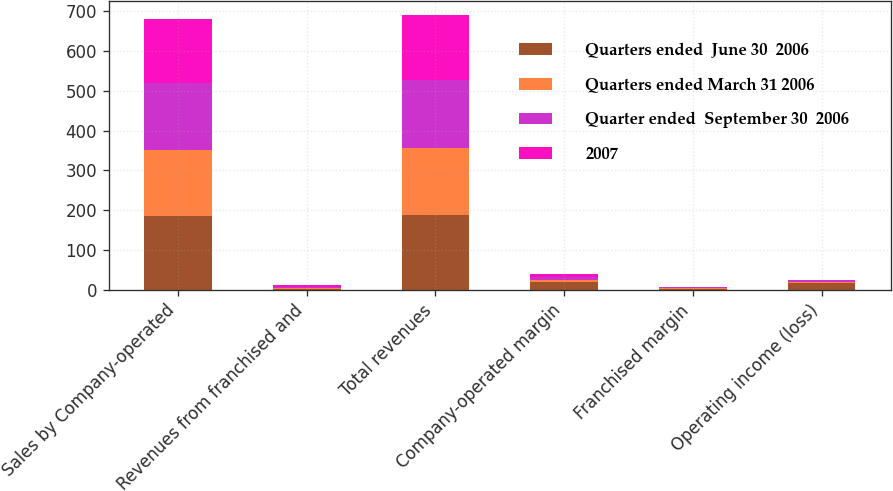Convert chart. <chart><loc_0><loc_0><loc_500><loc_500><stacked_bar_chart><ecel><fcel>Sales by Company-operated<fcel>Revenues from franchised and<fcel>Total revenues<fcel>Company-operated margin<fcel>Franchised margin<fcel>Operating income (loss)<nl><fcel>Quarters ended  June 30  2006<fcel>185.3<fcel>3.3<fcel>188.6<fcel>18.7<fcel>3<fcel>16.7<nl><fcel>Quarters ended March 31 2006<fcel>165.6<fcel>2.4<fcel>168<fcel>5.5<fcel>1.5<fcel>2.8<nl><fcel>Quarter ended  September 30  2006<fcel>168.5<fcel>2.6<fcel>171.1<fcel>6.9<fcel>1.6<fcel>5.7<nl><fcel>2007<fcel>160.3<fcel>2.7<fcel>163<fcel>9.1<fcel>2<fcel>0.6<nl></chart> 